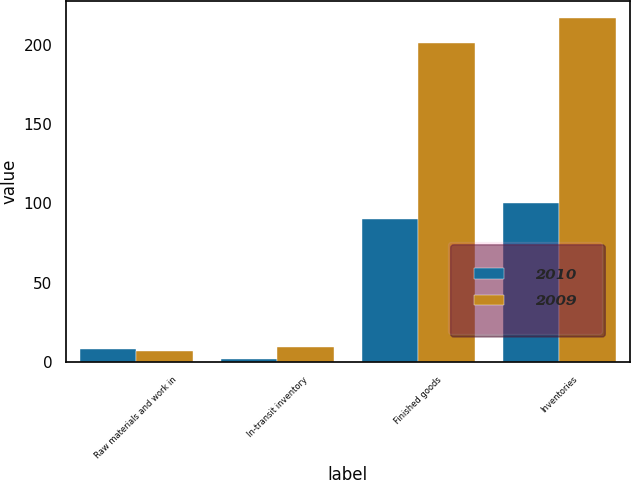<chart> <loc_0><loc_0><loc_500><loc_500><stacked_bar_chart><ecel><fcel>Raw materials and work in<fcel>In-transit inventory<fcel>Finished goods<fcel>Inventories<nl><fcel>2010<fcel>8<fcel>2<fcel>90<fcel>100<nl><fcel>2009<fcel>7<fcel>9<fcel>201<fcel>217<nl></chart> 